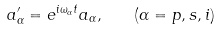Convert formula to latex. <formula><loc_0><loc_0><loc_500><loc_500>a ^ { \prime } _ { \alpha } = e ^ { i \omega _ { \alpha } t } a _ { \alpha } , \quad ( \alpha = p , s , i )</formula> 